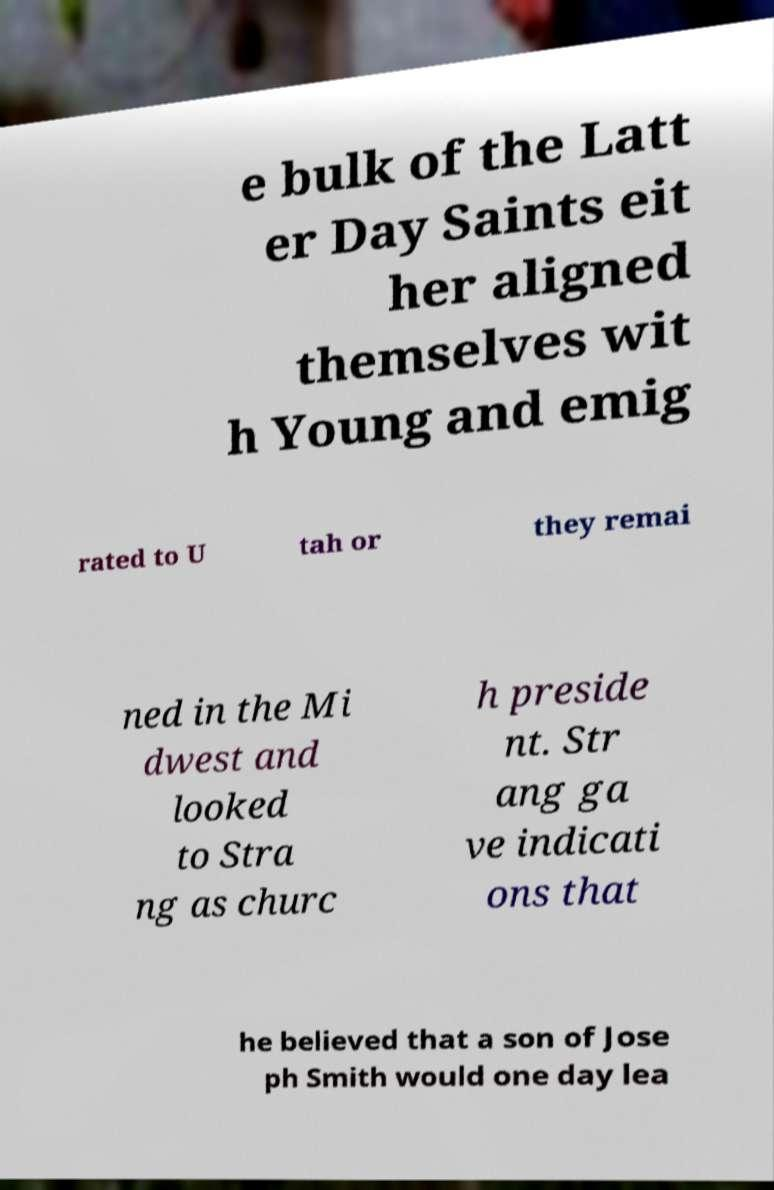What messages or text are displayed in this image? I need them in a readable, typed format. e bulk of the Latt er Day Saints eit her aligned themselves wit h Young and emig rated to U tah or they remai ned in the Mi dwest and looked to Stra ng as churc h preside nt. Str ang ga ve indicati ons that he believed that a son of Jose ph Smith would one day lea 